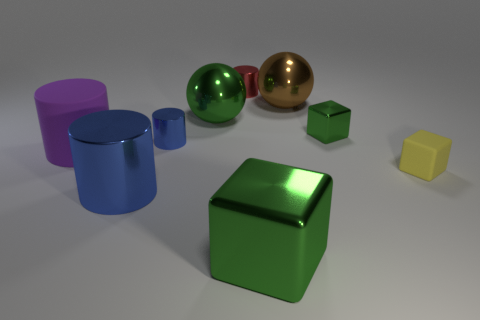There is a blue object behind the purple rubber object; is it the same size as the big blue shiny cylinder?
Your response must be concise. No. There is a metallic cylinder behind the big green thing to the left of the red metallic cylinder; how many shiny objects are in front of it?
Your answer should be very brief. 6. What is the size of the cylinder that is both in front of the tiny blue metallic object and right of the large purple rubber cylinder?
Keep it short and to the point. Large. How many other objects are there of the same shape as the tiny yellow matte thing?
Give a very brief answer. 2. There is a large green cube; what number of small blue shiny cylinders are to the left of it?
Keep it short and to the point. 1. Are there fewer brown metal things that are on the right side of the small green metal thing than big shiny blocks left of the red metal cylinder?
Keep it short and to the point. No. What shape is the big metal object that is to the left of the small metal object left of the tiny metal thing behind the big brown thing?
Make the answer very short. Cylinder. What is the shape of the big shiny thing that is left of the big green block and behind the large blue shiny thing?
Offer a very short reply. Sphere. Is there a cylinder made of the same material as the yellow thing?
Ensure brevity in your answer.  Yes. There is another cube that is the same color as the large block; what is its size?
Your response must be concise. Small. 